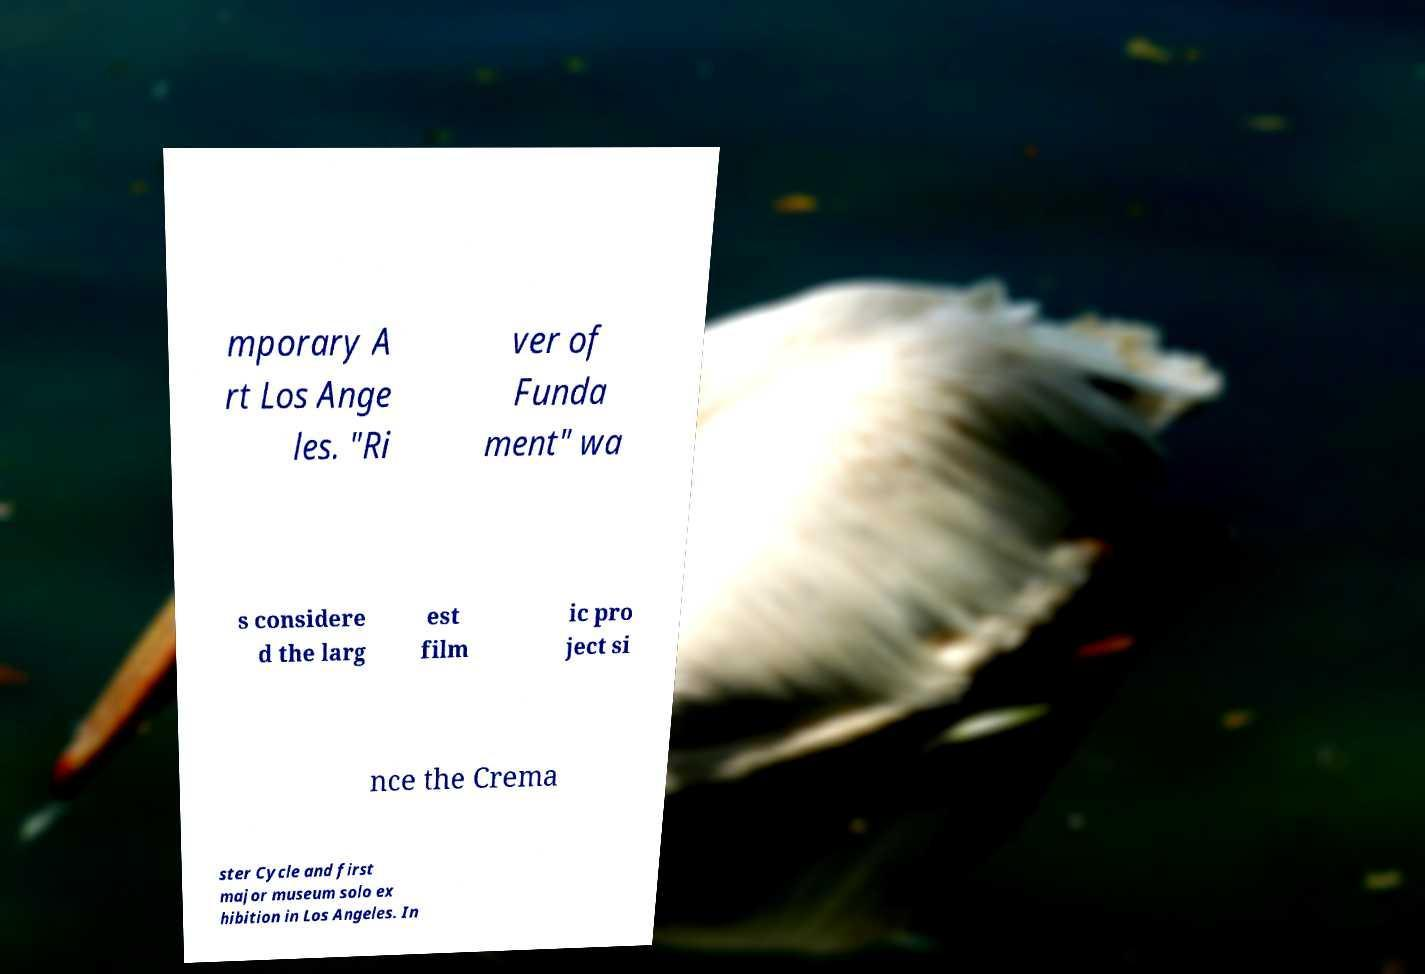There's text embedded in this image that I need extracted. Can you transcribe it verbatim? mporary A rt Los Ange les. "Ri ver of Funda ment" wa s considere d the larg est film ic pro ject si nce the Crema ster Cycle and first major museum solo ex hibition in Los Angeles. In 